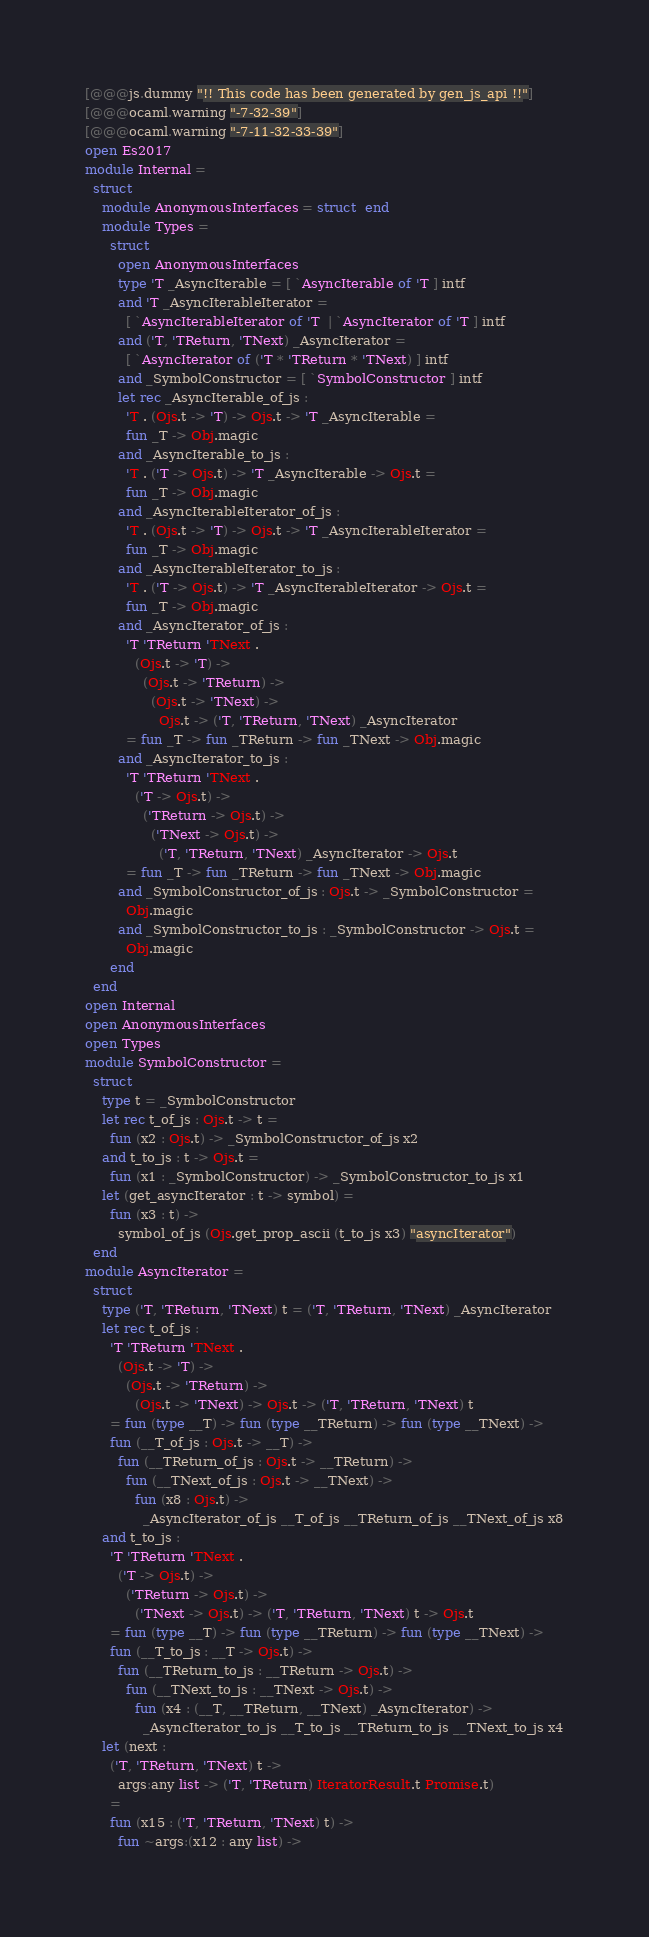<code> <loc_0><loc_0><loc_500><loc_500><_OCaml_>[@@@js.dummy "!! This code has been generated by gen_js_api !!"]
[@@@ocaml.warning "-7-32-39"]
[@@@ocaml.warning "-7-11-32-33-39"]
open Es2017
module Internal =
  struct
    module AnonymousInterfaces = struct  end
    module Types =
      struct
        open AnonymousInterfaces
        type 'T _AsyncIterable = [ `AsyncIterable of 'T ] intf
        and 'T _AsyncIterableIterator =
          [ `AsyncIterableIterator of 'T  | `AsyncIterator of 'T ] intf
        and ('T, 'TReturn, 'TNext) _AsyncIterator =
          [ `AsyncIterator of ('T * 'TReturn * 'TNext) ] intf
        and _SymbolConstructor = [ `SymbolConstructor ] intf
        let rec _AsyncIterable_of_js :
          'T . (Ojs.t -> 'T) -> Ojs.t -> 'T _AsyncIterable =
          fun _T -> Obj.magic
        and _AsyncIterable_to_js :
          'T . ('T -> Ojs.t) -> 'T _AsyncIterable -> Ojs.t =
          fun _T -> Obj.magic
        and _AsyncIterableIterator_of_js :
          'T . (Ojs.t -> 'T) -> Ojs.t -> 'T _AsyncIterableIterator =
          fun _T -> Obj.magic
        and _AsyncIterableIterator_to_js :
          'T . ('T -> Ojs.t) -> 'T _AsyncIterableIterator -> Ojs.t =
          fun _T -> Obj.magic
        and _AsyncIterator_of_js :
          'T 'TReturn 'TNext .
            (Ojs.t -> 'T) ->
              (Ojs.t -> 'TReturn) ->
                (Ojs.t -> 'TNext) ->
                  Ojs.t -> ('T, 'TReturn, 'TNext) _AsyncIterator
          = fun _T -> fun _TReturn -> fun _TNext -> Obj.magic
        and _AsyncIterator_to_js :
          'T 'TReturn 'TNext .
            ('T -> Ojs.t) ->
              ('TReturn -> Ojs.t) ->
                ('TNext -> Ojs.t) ->
                  ('T, 'TReturn, 'TNext) _AsyncIterator -> Ojs.t
          = fun _T -> fun _TReturn -> fun _TNext -> Obj.magic
        and _SymbolConstructor_of_js : Ojs.t -> _SymbolConstructor =
          Obj.magic
        and _SymbolConstructor_to_js : _SymbolConstructor -> Ojs.t =
          Obj.magic
      end
  end
open Internal
open AnonymousInterfaces
open Types
module SymbolConstructor =
  struct
    type t = _SymbolConstructor
    let rec t_of_js : Ojs.t -> t =
      fun (x2 : Ojs.t) -> _SymbolConstructor_of_js x2
    and t_to_js : t -> Ojs.t =
      fun (x1 : _SymbolConstructor) -> _SymbolConstructor_to_js x1
    let (get_asyncIterator : t -> symbol) =
      fun (x3 : t) ->
        symbol_of_js (Ojs.get_prop_ascii (t_to_js x3) "asyncIterator")
  end
module AsyncIterator =
  struct
    type ('T, 'TReturn, 'TNext) t = ('T, 'TReturn, 'TNext) _AsyncIterator
    let rec t_of_js :
      'T 'TReturn 'TNext .
        (Ojs.t -> 'T) ->
          (Ojs.t -> 'TReturn) ->
            (Ojs.t -> 'TNext) -> Ojs.t -> ('T, 'TReturn, 'TNext) t
      = fun (type __T) -> fun (type __TReturn) -> fun (type __TNext) ->
      fun (__T_of_js : Ojs.t -> __T) ->
        fun (__TReturn_of_js : Ojs.t -> __TReturn) ->
          fun (__TNext_of_js : Ojs.t -> __TNext) ->
            fun (x8 : Ojs.t) ->
              _AsyncIterator_of_js __T_of_js __TReturn_of_js __TNext_of_js x8
    and t_to_js :
      'T 'TReturn 'TNext .
        ('T -> Ojs.t) ->
          ('TReturn -> Ojs.t) ->
            ('TNext -> Ojs.t) -> ('T, 'TReturn, 'TNext) t -> Ojs.t
      = fun (type __T) -> fun (type __TReturn) -> fun (type __TNext) ->
      fun (__T_to_js : __T -> Ojs.t) ->
        fun (__TReturn_to_js : __TReturn -> Ojs.t) ->
          fun (__TNext_to_js : __TNext -> Ojs.t) ->
            fun (x4 : (__T, __TReturn, __TNext) _AsyncIterator) ->
              _AsyncIterator_to_js __T_to_js __TReturn_to_js __TNext_to_js x4
    let (next :
      ('T, 'TReturn, 'TNext) t ->
        args:any list -> ('T, 'TReturn) IteratorResult.t Promise.t)
      =
      fun (x15 : ('T, 'TReturn, 'TNext) t) ->
        fun ~args:(x12 : any list) -></code> 